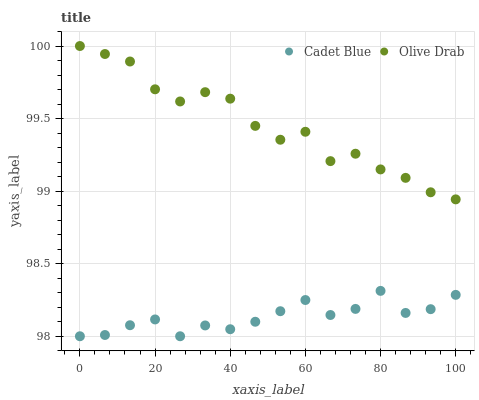Does Cadet Blue have the minimum area under the curve?
Answer yes or no. Yes. Does Olive Drab have the maximum area under the curve?
Answer yes or no. Yes. Does Olive Drab have the minimum area under the curve?
Answer yes or no. No. Is Cadet Blue the smoothest?
Answer yes or no. Yes. Is Olive Drab the roughest?
Answer yes or no. Yes. Is Olive Drab the smoothest?
Answer yes or no. No. Does Cadet Blue have the lowest value?
Answer yes or no. Yes. Does Olive Drab have the lowest value?
Answer yes or no. No. Does Olive Drab have the highest value?
Answer yes or no. Yes. Is Cadet Blue less than Olive Drab?
Answer yes or no. Yes. Is Olive Drab greater than Cadet Blue?
Answer yes or no. Yes. Does Cadet Blue intersect Olive Drab?
Answer yes or no. No. 